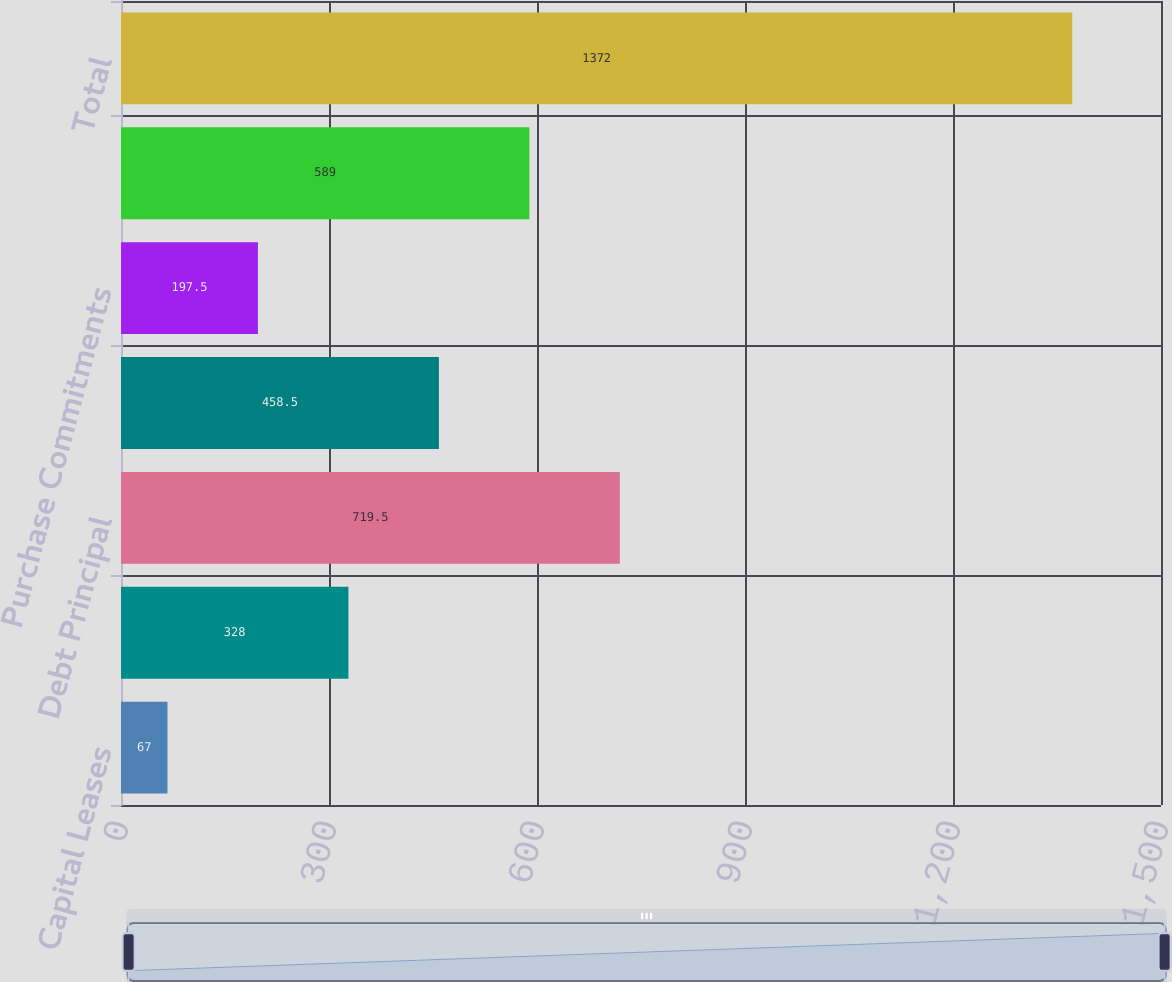Convert chart to OTSL. <chart><loc_0><loc_0><loc_500><loc_500><bar_chart><fcel>Capital Leases<fcel>Operating Leases<fcel>Debt Principal<fcel>Debt Interest<fcel>Purchase Commitments<fcel>Pension Fundings<fcel>Total<nl><fcel>67<fcel>328<fcel>719.5<fcel>458.5<fcel>197.5<fcel>589<fcel>1372<nl></chart> 